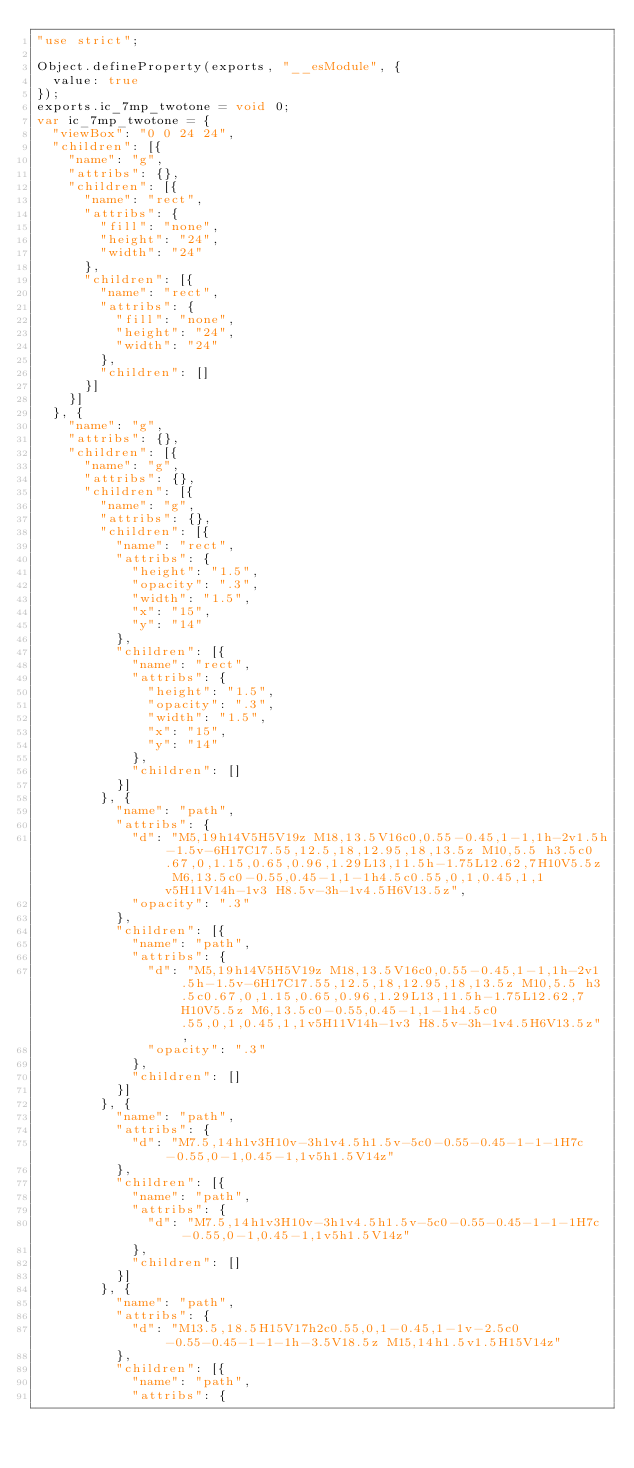<code> <loc_0><loc_0><loc_500><loc_500><_JavaScript_>"use strict";

Object.defineProperty(exports, "__esModule", {
  value: true
});
exports.ic_7mp_twotone = void 0;
var ic_7mp_twotone = {
  "viewBox": "0 0 24 24",
  "children": [{
    "name": "g",
    "attribs": {},
    "children": [{
      "name": "rect",
      "attribs": {
        "fill": "none",
        "height": "24",
        "width": "24"
      },
      "children": [{
        "name": "rect",
        "attribs": {
          "fill": "none",
          "height": "24",
          "width": "24"
        },
        "children": []
      }]
    }]
  }, {
    "name": "g",
    "attribs": {},
    "children": [{
      "name": "g",
      "attribs": {},
      "children": [{
        "name": "g",
        "attribs": {},
        "children": [{
          "name": "rect",
          "attribs": {
            "height": "1.5",
            "opacity": ".3",
            "width": "1.5",
            "x": "15",
            "y": "14"
          },
          "children": [{
            "name": "rect",
            "attribs": {
              "height": "1.5",
              "opacity": ".3",
              "width": "1.5",
              "x": "15",
              "y": "14"
            },
            "children": []
          }]
        }, {
          "name": "path",
          "attribs": {
            "d": "M5,19h14V5H5V19z M18,13.5V16c0,0.55-0.45,1-1,1h-2v1.5h-1.5v-6H17C17.55,12.5,18,12.95,18,13.5z M10,5.5 h3.5c0.67,0,1.15,0.65,0.96,1.29L13,11.5h-1.75L12.62,7H10V5.5z M6,13.5c0-0.55,0.45-1,1-1h4.5c0.55,0,1,0.45,1,1v5H11V14h-1v3 H8.5v-3h-1v4.5H6V13.5z",
            "opacity": ".3"
          },
          "children": [{
            "name": "path",
            "attribs": {
              "d": "M5,19h14V5H5V19z M18,13.5V16c0,0.55-0.45,1-1,1h-2v1.5h-1.5v-6H17C17.55,12.5,18,12.95,18,13.5z M10,5.5 h3.5c0.67,0,1.15,0.65,0.96,1.29L13,11.5h-1.75L12.62,7H10V5.5z M6,13.5c0-0.55,0.45-1,1-1h4.5c0.55,0,1,0.45,1,1v5H11V14h-1v3 H8.5v-3h-1v4.5H6V13.5z",
              "opacity": ".3"
            },
            "children": []
          }]
        }, {
          "name": "path",
          "attribs": {
            "d": "M7.5,14h1v3H10v-3h1v4.5h1.5v-5c0-0.55-0.45-1-1-1H7c-0.55,0-1,0.45-1,1v5h1.5V14z"
          },
          "children": [{
            "name": "path",
            "attribs": {
              "d": "M7.5,14h1v3H10v-3h1v4.5h1.5v-5c0-0.55-0.45-1-1-1H7c-0.55,0-1,0.45-1,1v5h1.5V14z"
            },
            "children": []
          }]
        }, {
          "name": "path",
          "attribs": {
            "d": "M13.5,18.5H15V17h2c0.55,0,1-0.45,1-1v-2.5c0-0.55-0.45-1-1-1h-3.5V18.5z M15,14h1.5v1.5H15V14z"
          },
          "children": [{
            "name": "path",
            "attribs": {</code> 